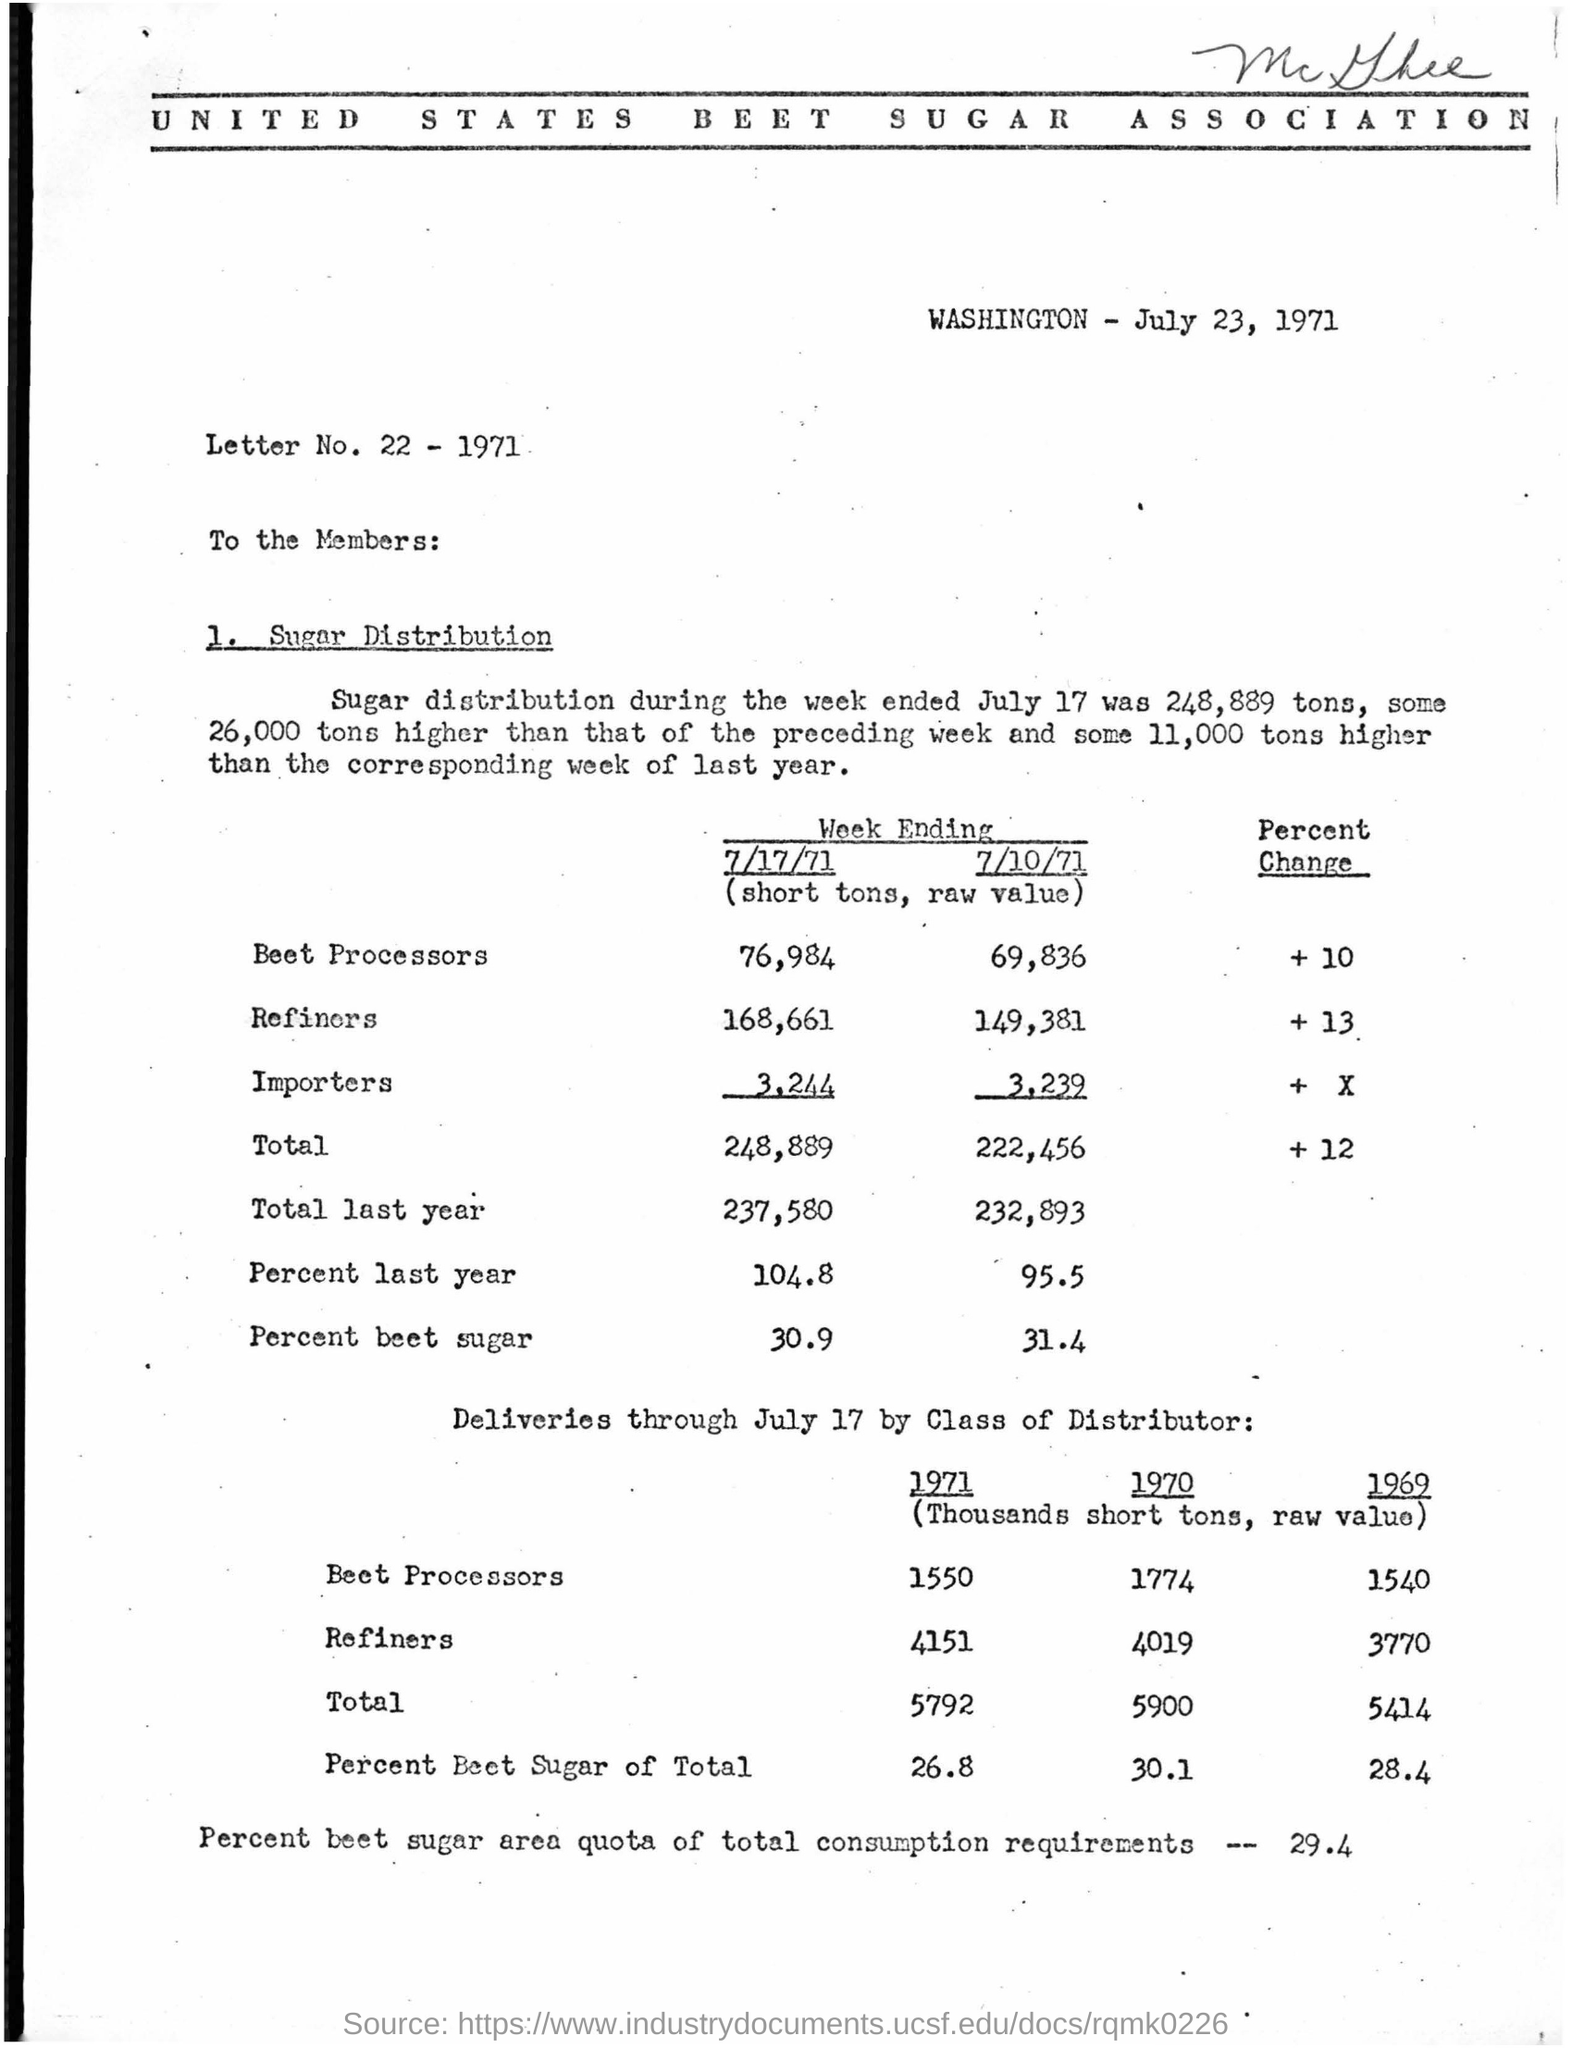Highlight a few significant elements in this photo. The letter is addressed to the members. The letter is prepared at a place in Washington. This document was created on July 23, 1971. 